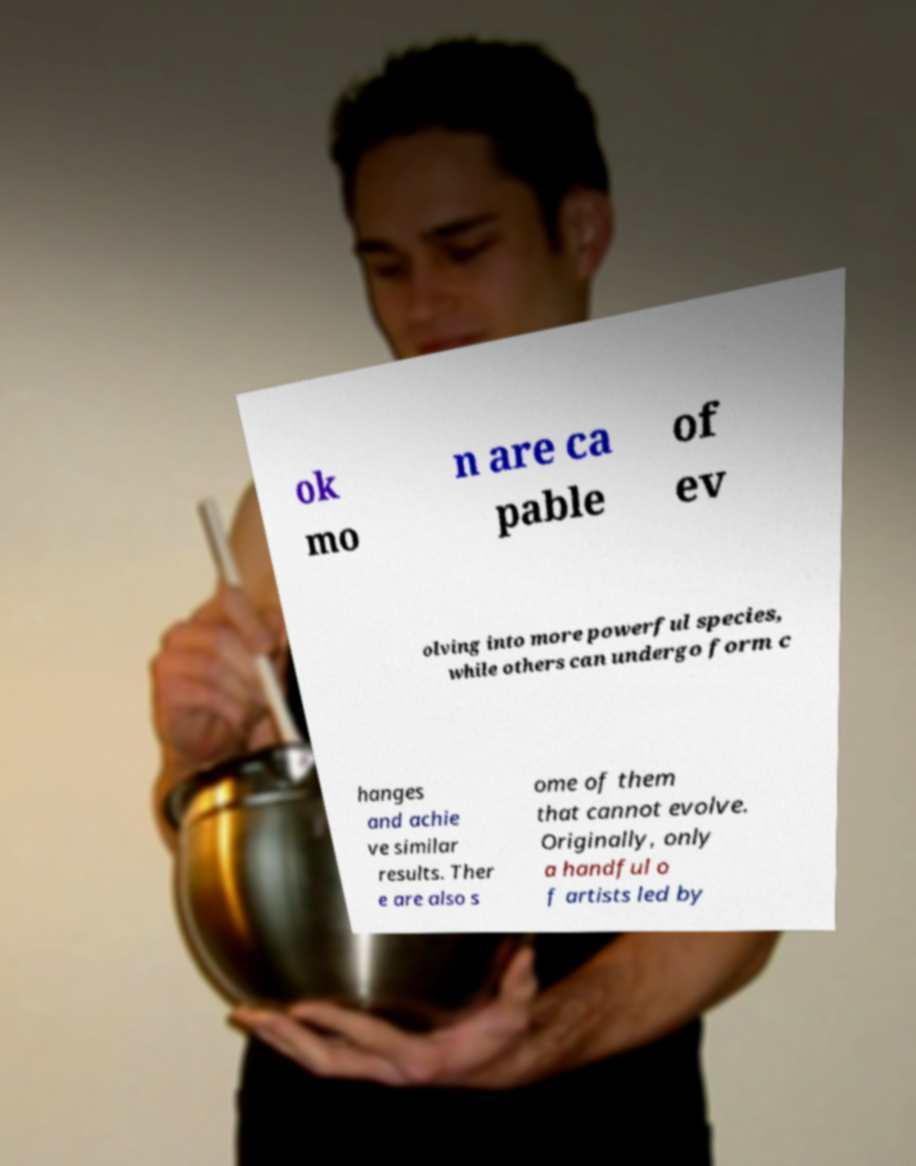Can you read and provide the text displayed in the image?This photo seems to have some interesting text. Can you extract and type it out for me? ok mo n are ca pable of ev olving into more powerful species, while others can undergo form c hanges and achie ve similar results. Ther e are also s ome of them that cannot evolve. Originally, only a handful o f artists led by 